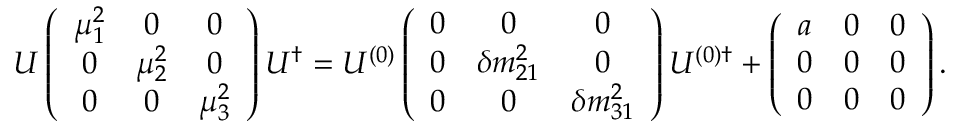<formula> <loc_0><loc_0><loc_500><loc_500>U \left ( \begin{array} { c c c } { { \mu _ { 1 } ^ { 2 } } } & { 0 } & { 0 } \\ { 0 } & { { \mu _ { 2 } ^ { 2 } } } & { 0 } \\ { 0 } & { 0 } & { { \mu _ { 3 } ^ { 2 } } } \end{array} \right ) U ^ { \dagger } = U ^ { ( 0 ) } \left ( \begin{array} { c c c } { 0 } & { 0 } & { 0 } \\ { 0 } & { { \delta m _ { 2 1 } ^ { 2 } } } & { 0 } \\ { 0 } & { 0 } & { { \delta m _ { 3 1 } ^ { 2 } } } \end{array} \right ) U ^ { ( 0 ) \dagger } + \left ( \begin{array} { c c c } { a } & { 0 } & { 0 } \\ { 0 } & { 0 } & { 0 } \\ { 0 } & { 0 } & { 0 } \end{array} \right ) .</formula> 